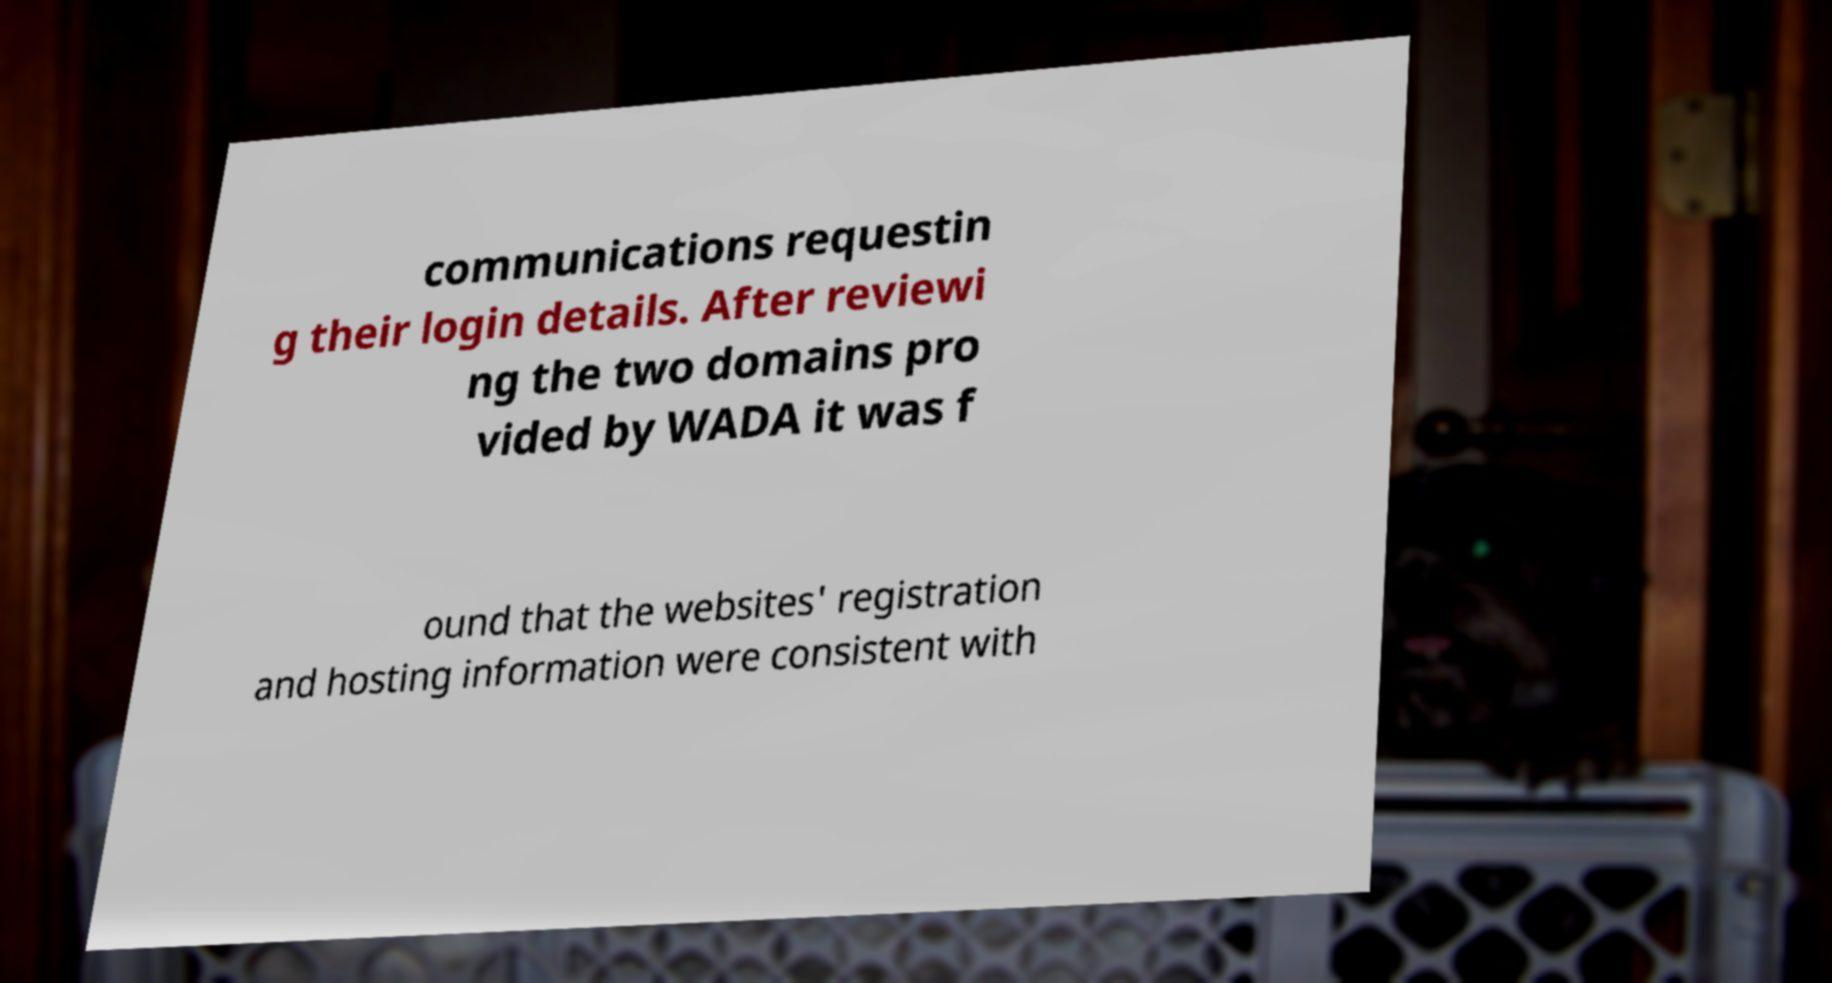Could you assist in decoding the text presented in this image and type it out clearly? communications requestin g their login details. After reviewi ng the two domains pro vided by WADA it was f ound that the websites' registration and hosting information were consistent with 